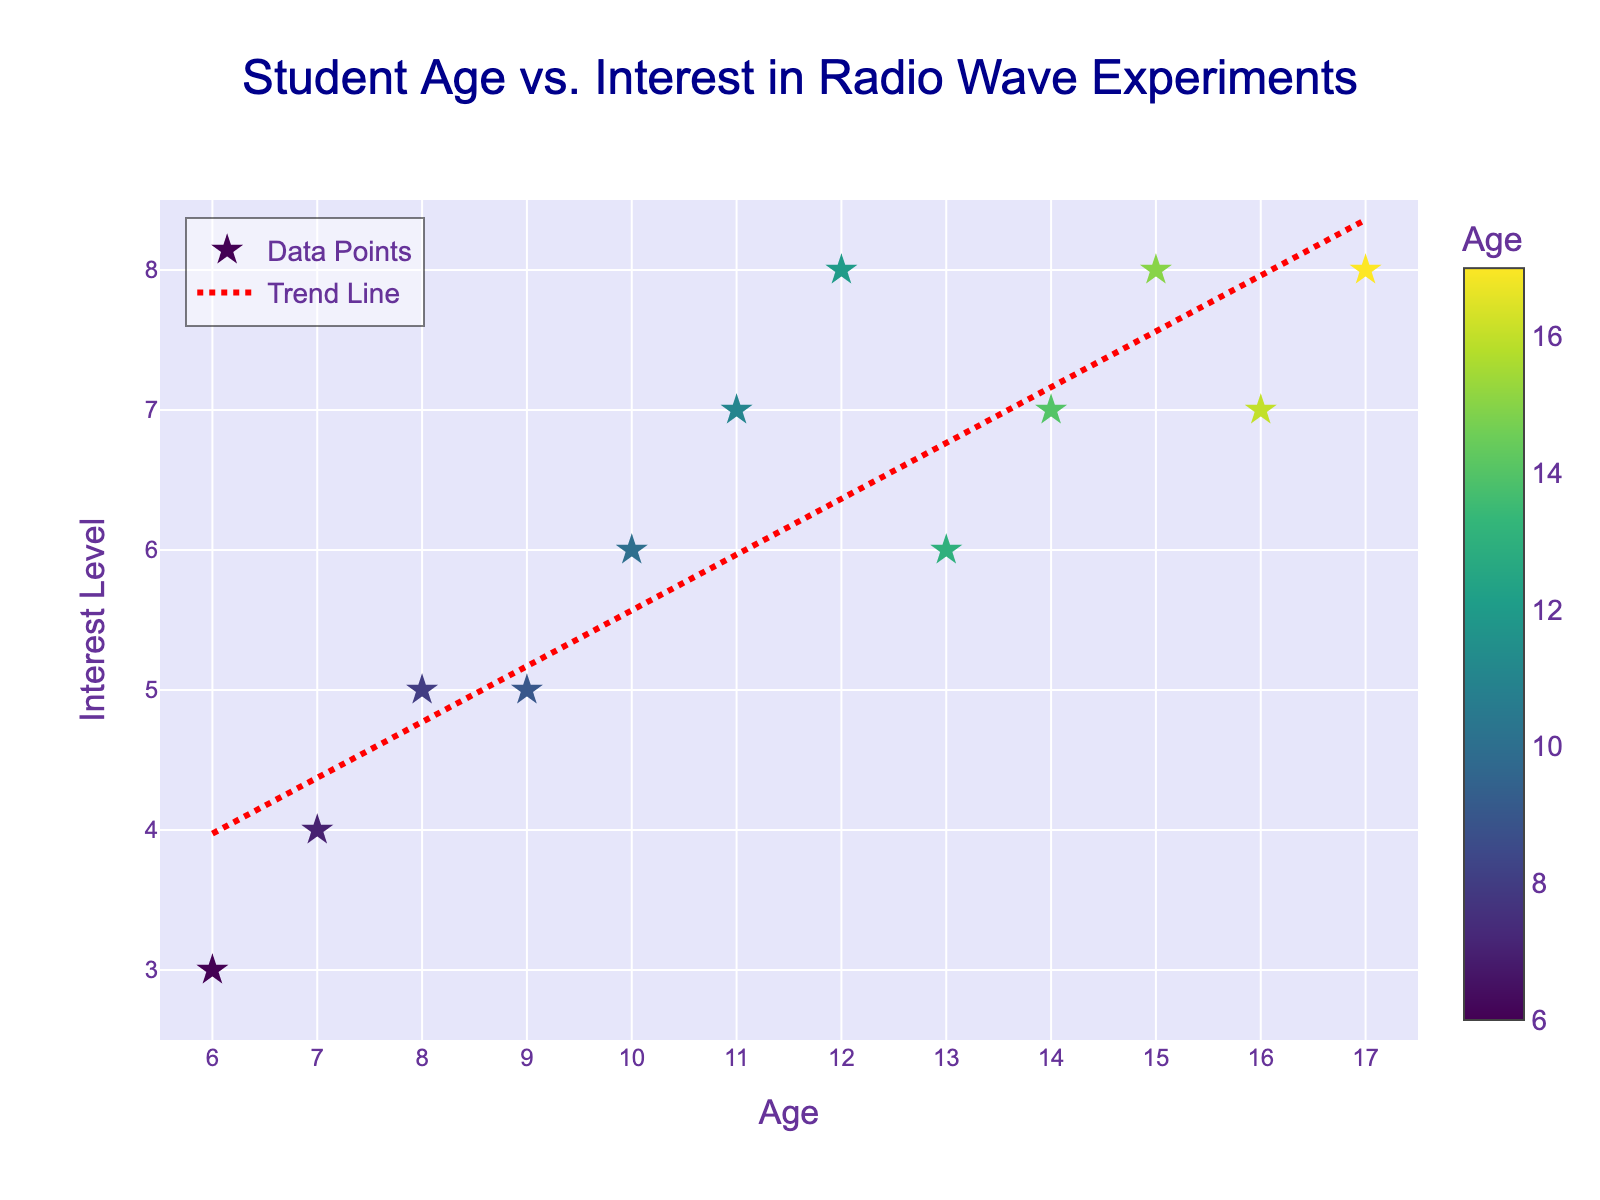What is the title of the plot? The title of the plot is displayed at the top center with the text “Student Age vs. Interest in Radio Wave Experiments”.
Answer: Student Age vs. Interest in Radio Wave Experiments What are the x-axis and y-axis labels? The x-axis is labeled "Age" and the y-axis is labeled "Interest Level," as indicated below each axis.
Answer: Age and Interest Level How many data points are there in the scatter plot? By counting the individual points on the plot, you can see there are 12 data points.
Answer: 12 What is the color of the trend line? The trend line is depicted in red with a dashed pattern.
Answer: Red What age group has the lowest interest level? The lowest interest level on the y-axis is 3, which corresponds to the age of 6.
Answer: Age 6 How many age groups have an interest level of 8? By examining the scatter plot, you observe that ages 12, 15, and 17 each have an interest level of 8.
Answer: 3 What is the interest level of the oldest student? The oldest student is 17 years old, and their interest level is 8 based on the data.
Answer: 8 Which age group shows a deviation from the trend line, and how does it deviate? The age group 13 shows a deviation, with the data point falling below the trend line, showing less interest than expected.
Answer: Age 13 deviates below Is there an increasing or decreasing trend in the interest levels as age increases? The trend line shows an upward slope as age increases, indicating an increasing trend in interest levels.
Answer: Increasing What is the average interest level of students aged 10 and above? The interest levels for the ages 10, 11, 12, 13, 14, 15, 16, and 17 are 6, 7, 8, 6, 7, 8, 7, and 8 respectively. Adding these gives 57, and dividing by 8 gives an average of 7.125.
Answer: 7.125 